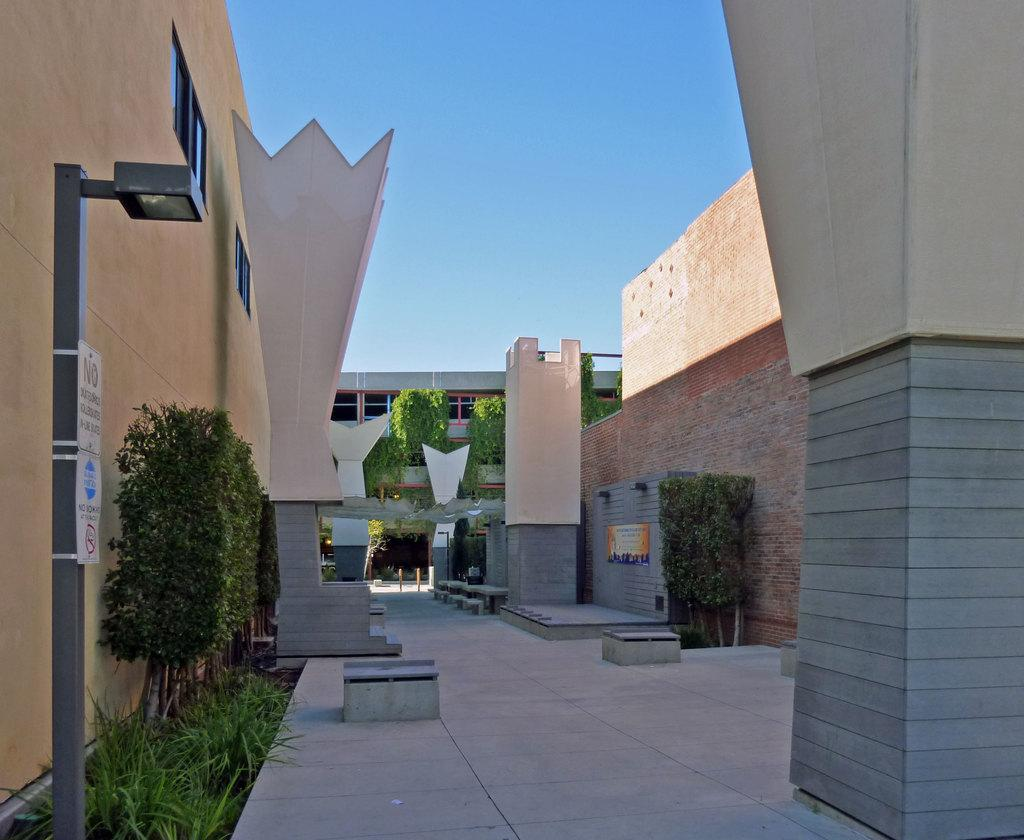<image>
Relay a brief, clear account of the picture shown. A sign with the word NO on it is posted on a lamppost in a courtyard. 